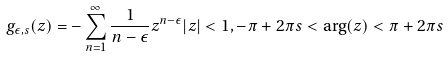Convert formula to latex. <formula><loc_0><loc_0><loc_500><loc_500>g _ { \epsilon , s } ( z ) = - \sum _ { n = 1 } ^ { \infty } \frac { 1 } { n - \epsilon } z ^ { n - \epsilon } | z | < 1 , - \pi + 2 \pi s < \arg ( z ) < \pi + 2 \pi s</formula> 